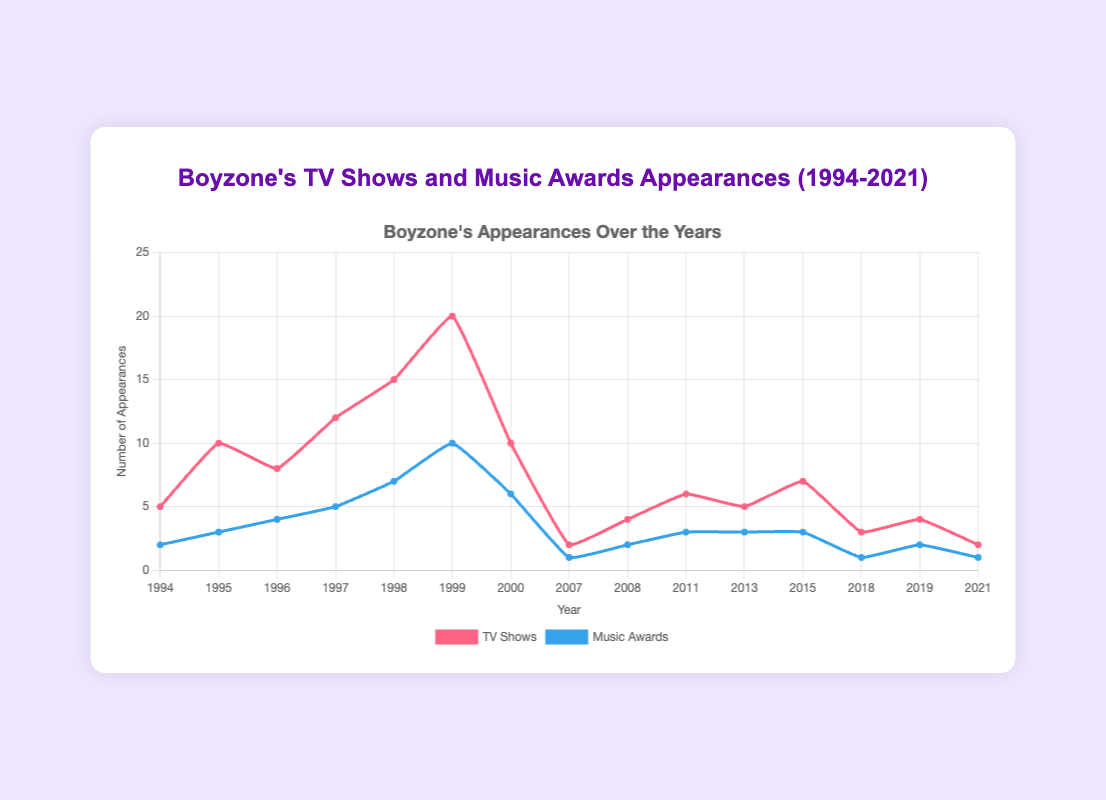How many TV show appearances did Boyzone have in the years they won 3 music awards? First, identify the years with 3 music awards: 1995, 2011, 2013, 2015. Then, sum the TV show appearances for these years: 10 (1995) + 6 (2011) + 5 (2013) + 7 (2015) = 28
Answer: 28 Compare the number of TV show appearances in the year 1999 to 2000. Which year had more? For 1999, the number of TV show appearances is 20. For 2000, it is 10. Clearly, 1999 had more TV show appearances than 2000.
Answer: 1999 What is the trend in music award appearances from 1994 to 1999? The number of music award appearances increases each year from 2 in 1994 to 10 in 1999. This shows a positive trend in music award appearances during these years.
Answer: Positive trend For which years did Boyzone have twice as many TV show appearances as music award appearances? To find this, check for each year where the number of TV show appearances is twice that of the music awards. The years are 1997 (12 vs. 5) and 2008 (4 vs. 2).
Answer: 1997, 2008 What is the maximum number of music award appearances Boyzone had in one year? Identify the highest point on the music awards line, which is in 1999 with 10 music award appearances.
Answer: 10 How does Boyzone’s presence on TV shows compare to their music award appearances in 2018? In 2018, there are 3 TV show appearances and 1 music award appearance, meaning TV show appearances were greater than music awards.
Answer: Greater What is the average number of TV show appearances between 2007 and 2019? Calculate the sum of TV show appearances from 2007 (2), 2008 (4), 2011 (6), 2013 (5), 2015 (7), 2018 (3), and 2019 (4), and divide by the number of years (7). The sum is 2+4+6+5+7+3+4 = 31. The average is 31/7 ≈ 4.43
Answer: ≈ 4.43 Describe the visual difference between the trend lines for TV shows and music awards from 1994 to 2000. The TV shows trend line sharply increases from 1994 to 1999 before dropping in 2000, whereas the music awards trend line steadily rises from 1994 to 1999 and has a drop in 2000 as well.
Answer: TV shows: sharp rise, then drop; Music awards: steady rise, then drop 